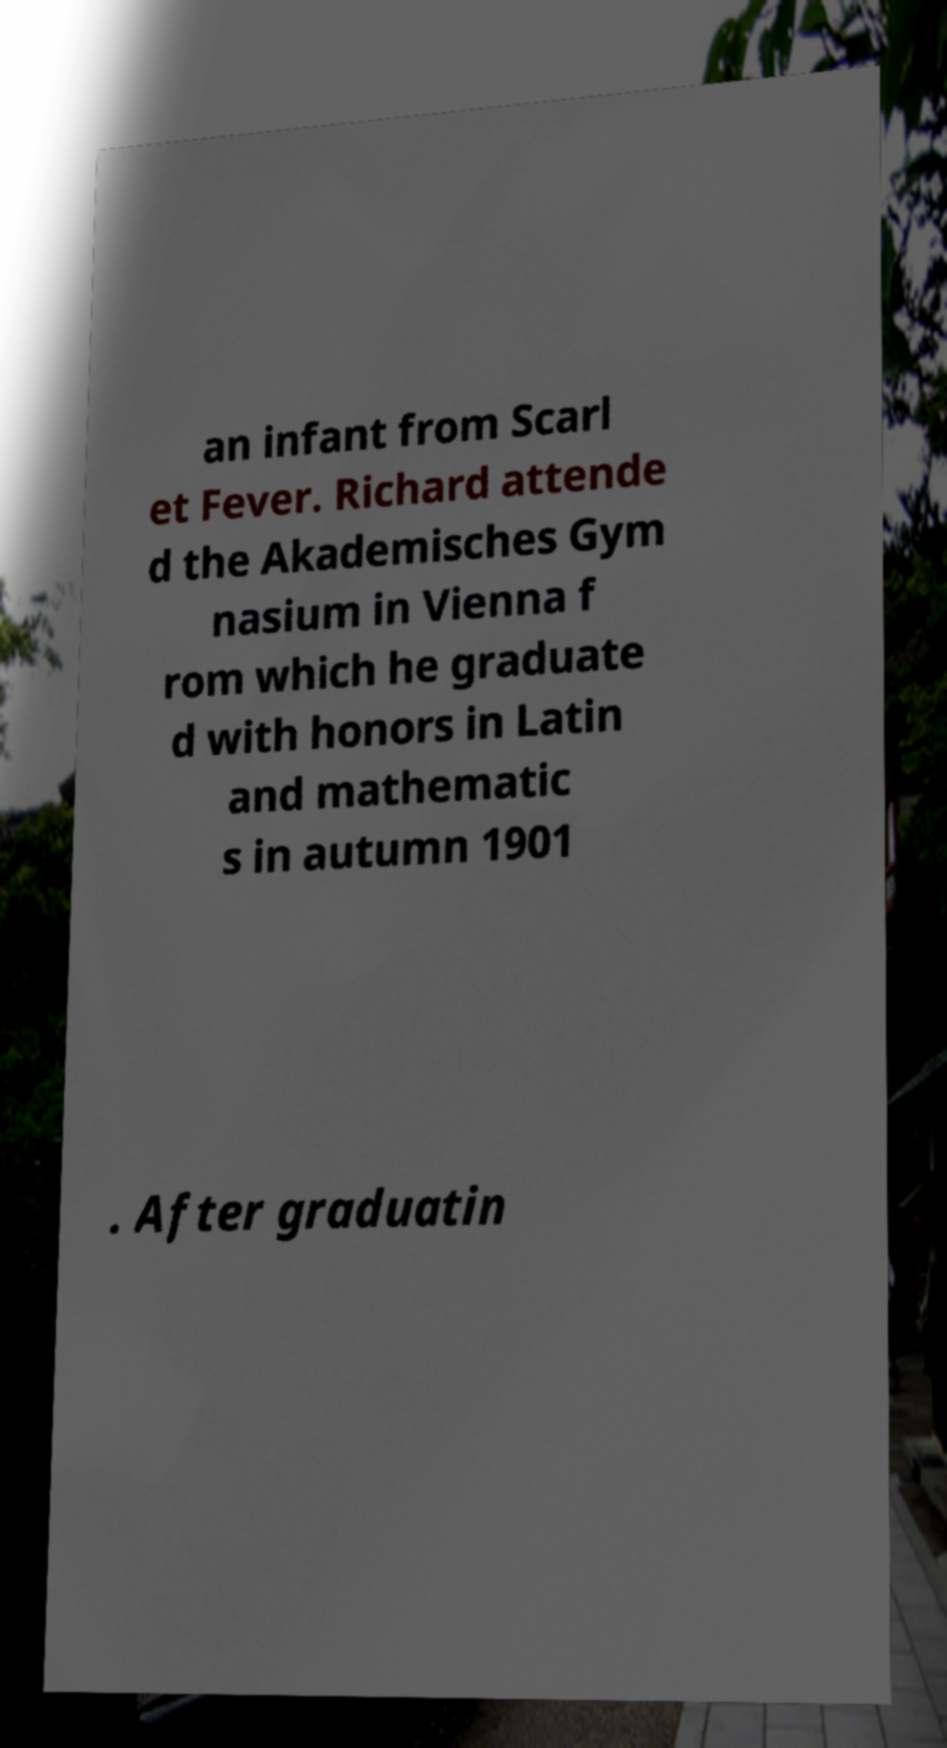I need the written content from this picture converted into text. Can you do that? an infant from Scarl et Fever. Richard attende d the Akademisches Gym nasium in Vienna f rom which he graduate d with honors in Latin and mathematic s in autumn 1901 . After graduatin 